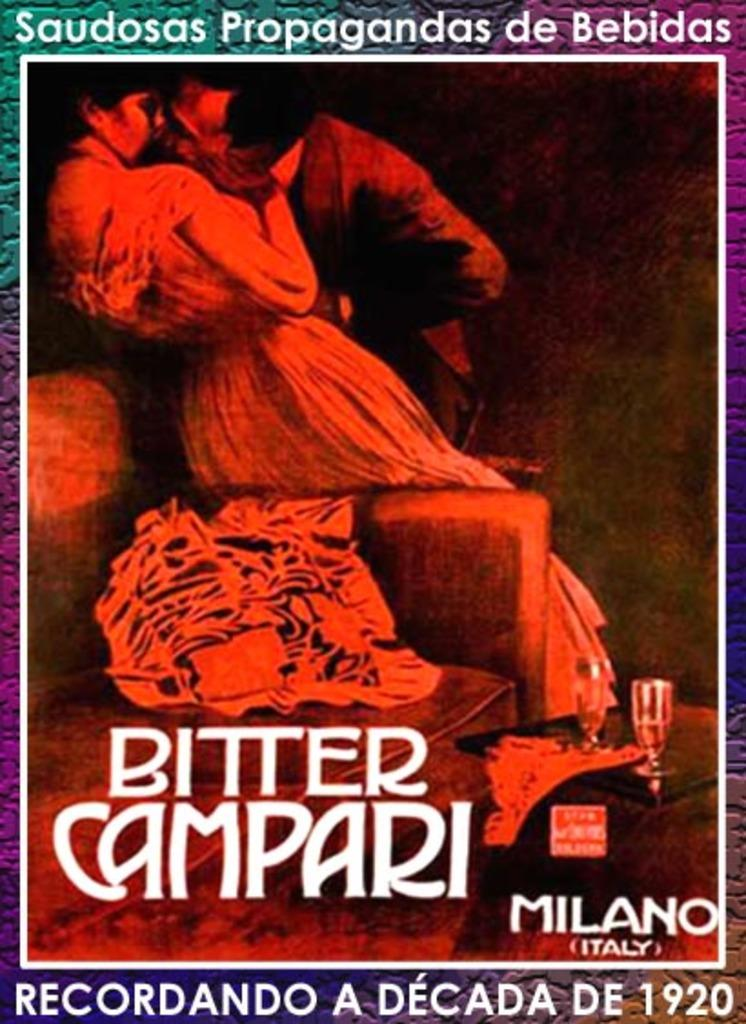Provide a one-sentence caption for the provided image. A flyer for the Bitter Campari taking place in Milan Italy. 